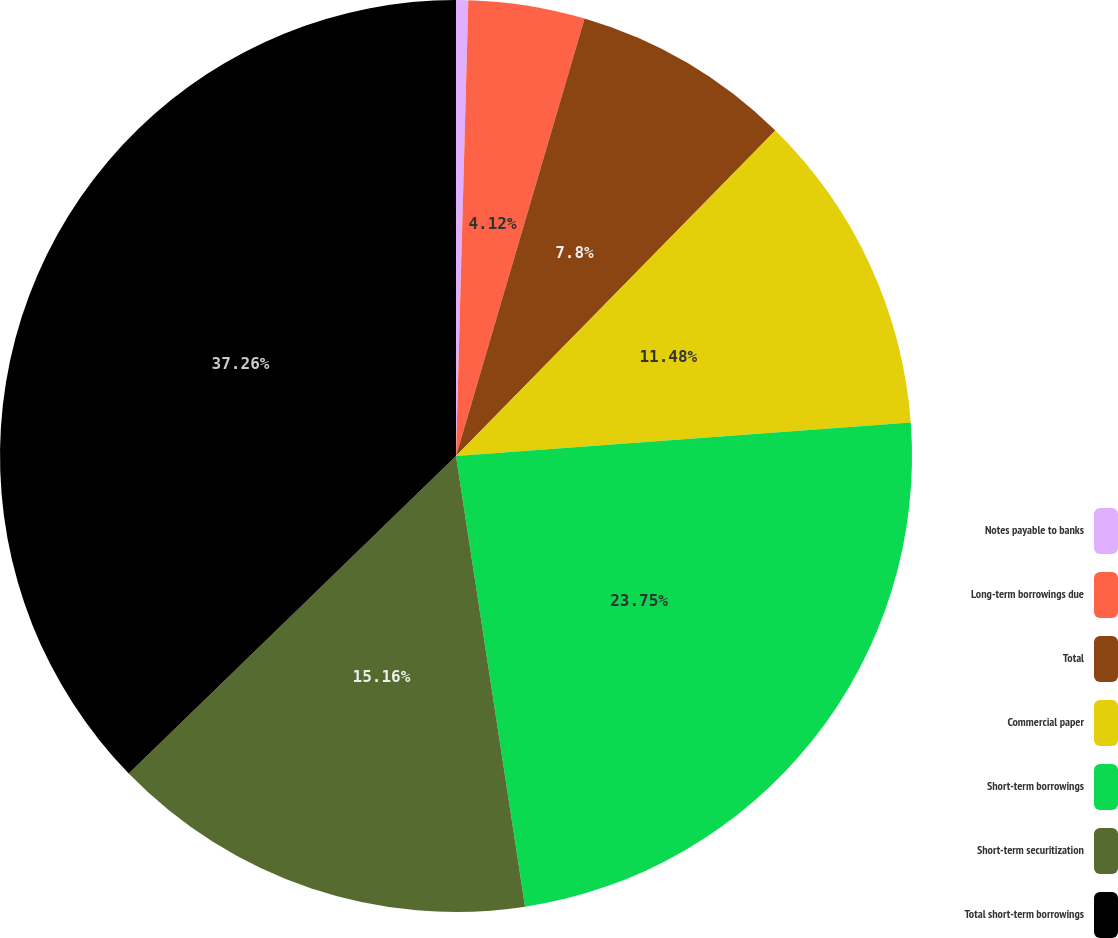<chart> <loc_0><loc_0><loc_500><loc_500><pie_chart><fcel>Notes payable to banks<fcel>Long-term borrowings due<fcel>Total<fcel>Commercial paper<fcel>Short-term borrowings<fcel>Short-term securitization<fcel>Total short-term borrowings<nl><fcel>0.43%<fcel>4.12%<fcel>7.8%<fcel>11.48%<fcel>23.75%<fcel>15.16%<fcel>37.26%<nl></chart> 